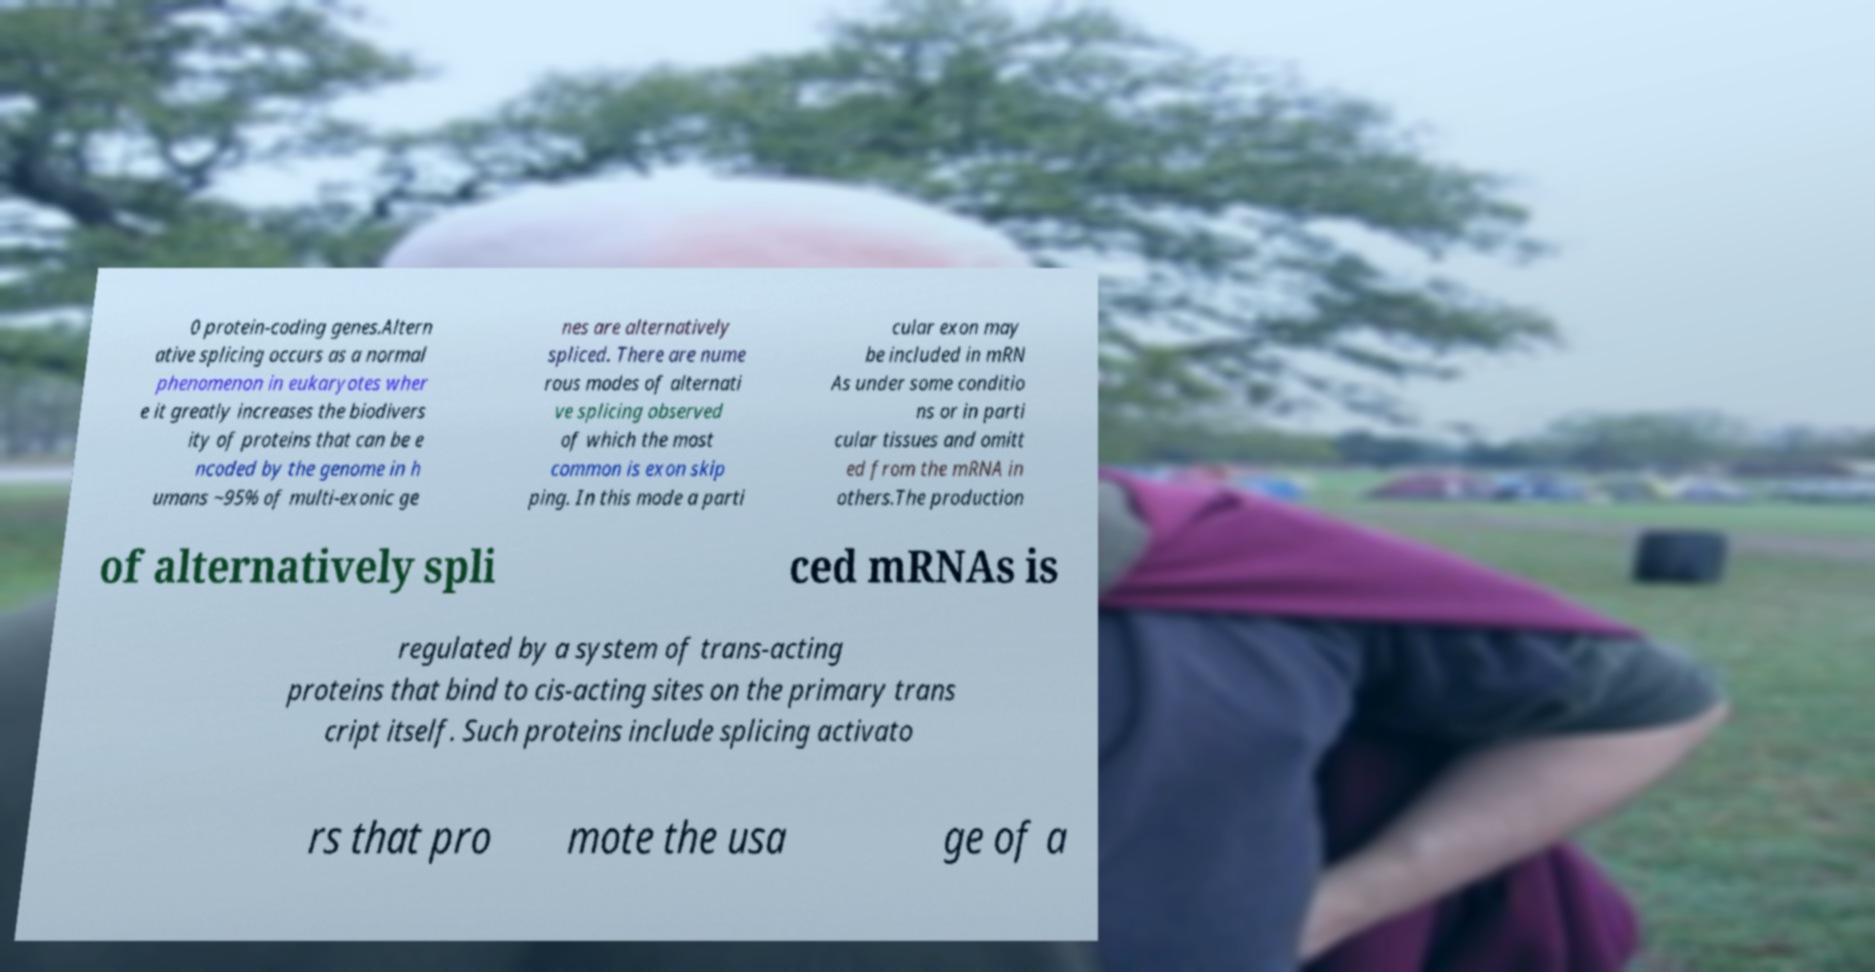What messages or text are displayed in this image? I need them in a readable, typed format. 0 protein-coding genes.Altern ative splicing occurs as a normal phenomenon in eukaryotes wher e it greatly increases the biodivers ity of proteins that can be e ncoded by the genome in h umans ~95% of multi-exonic ge nes are alternatively spliced. There are nume rous modes of alternati ve splicing observed of which the most common is exon skip ping. In this mode a parti cular exon may be included in mRN As under some conditio ns or in parti cular tissues and omitt ed from the mRNA in others.The production of alternatively spli ced mRNAs is regulated by a system of trans-acting proteins that bind to cis-acting sites on the primary trans cript itself. Such proteins include splicing activato rs that pro mote the usa ge of a 